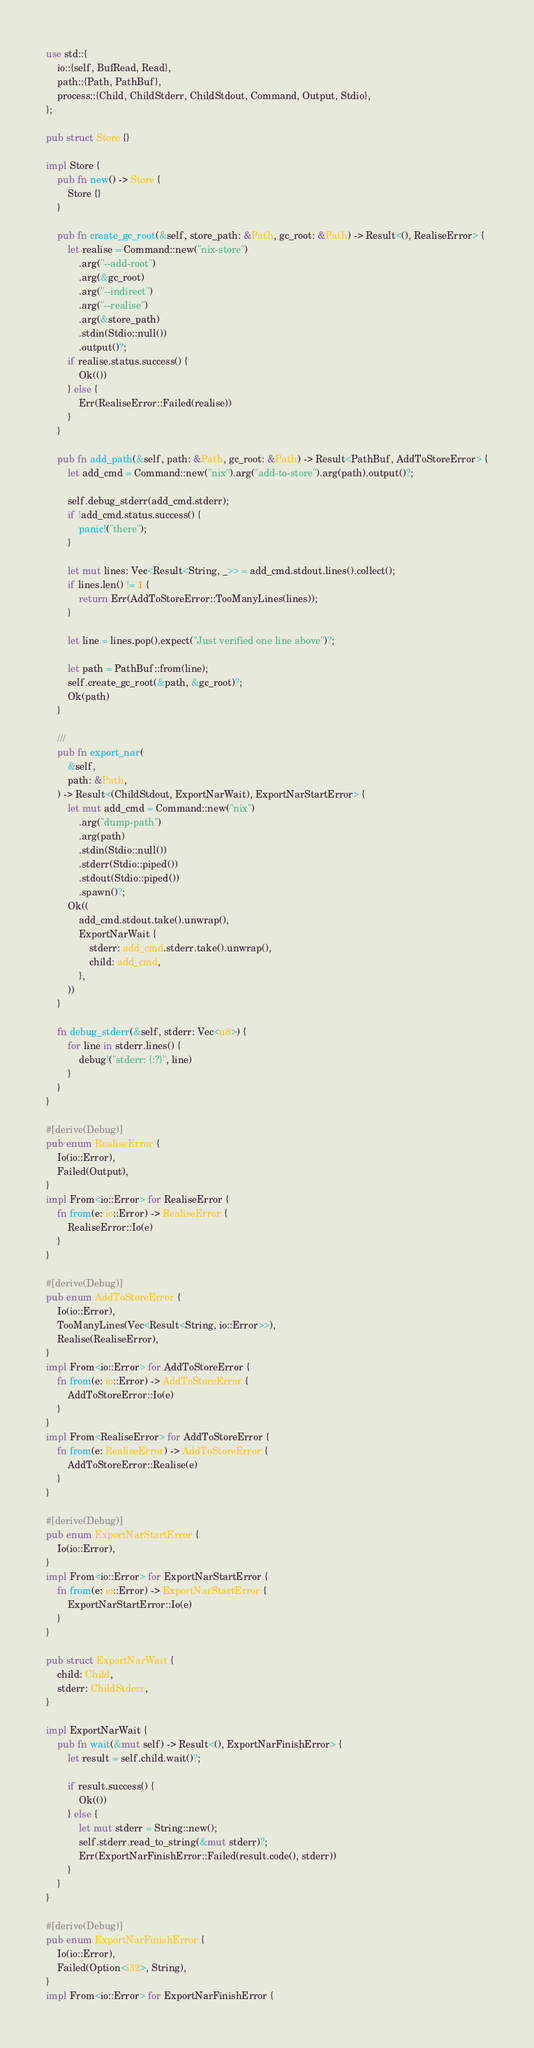<code> <loc_0><loc_0><loc_500><loc_500><_Rust_>use std::{
    io::{self, BufRead, Read},
    path::{Path, PathBuf},
    process::{Child, ChildStderr, ChildStdout, Command, Output, Stdio},
};

pub struct Store {}

impl Store {
    pub fn new() -> Store {
        Store {}
    }

    pub fn create_gc_root(&self, store_path: &Path, gc_root: &Path) -> Result<(), RealiseError> {
        let realise = Command::new("nix-store")
            .arg("--add-root")
            .arg(&gc_root)
            .arg("--indirect")
            .arg("--realise")
            .arg(&store_path)
            .stdin(Stdio::null())
            .output()?;
        if realise.status.success() {
            Ok(())
        } else {
            Err(RealiseError::Failed(realise))
        }
    }

    pub fn add_path(&self, path: &Path, gc_root: &Path) -> Result<PathBuf, AddToStoreError> {
        let add_cmd = Command::new("nix").arg("add-to-store").arg(path).output()?;

        self.debug_stderr(add_cmd.stderr);
        if !add_cmd.status.success() {
            panic!("there");
        }

        let mut lines: Vec<Result<String, _>> = add_cmd.stdout.lines().collect();
        if lines.len() != 1 {
            return Err(AddToStoreError::TooManyLines(lines));
        }

        let line = lines.pop().expect("Just verified one line above")?;

        let path = PathBuf::from(line);
        self.create_gc_root(&path, &gc_root)?;
        Ok(path)
    }

    ///
    pub fn export_nar(
        &self,
        path: &Path,
    ) -> Result<(ChildStdout, ExportNarWait), ExportNarStartError> {
        let mut add_cmd = Command::new("nix")
            .arg("dump-path")
            .arg(path)
            .stdin(Stdio::null())
            .stderr(Stdio::piped())
            .stdout(Stdio::piped())
            .spawn()?;
        Ok((
            add_cmd.stdout.take().unwrap(),
            ExportNarWait {
                stderr: add_cmd.stderr.take().unwrap(),
                child: add_cmd,
            },
        ))
    }

    fn debug_stderr(&self, stderr: Vec<u8>) {
        for line in stderr.lines() {
            debug!("stderr: {:?}", line)
        }
    }
}

#[derive(Debug)]
pub enum RealiseError {
    Io(io::Error),
    Failed(Output),
}
impl From<io::Error> for RealiseError {
    fn from(e: io::Error) -> RealiseError {
        RealiseError::Io(e)
    }
}

#[derive(Debug)]
pub enum AddToStoreError {
    Io(io::Error),
    TooManyLines(Vec<Result<String, io::Error>>),
    Realise(RealiseError),
}
impl From<io::Error> for AddToStoreError {
    fn from(e: io::Error) -> AddToStoreError {
        AddToStoreError::Io(e)
    }
}
impl From<RealiseError> for AddToStoreError {
    fn from(e: RealiseError) -> AddToStoreError {
        AddToStoreError::Realise(e)
    }
}

#[derive(Debug)]
pub enum ExportNarStartError {
    Io(io::Error),
}
impl From<io::Error> for ExportNarStartError {
    fn from(e: io::Error) -> ExportNarStartError {
        ExportNarStartError::Io(e)
    }
}

pub struct ExportNarWait {
    child: Child,
    stderr: ChildStderr,
}

impl ExportNarWait {
    pub fn wait(&mut self) -> Result<(), ExportNarFinishError> {
        let result = self.child.wait()?;

        if result.success() {
            Ok(())
        } else {
            let mut stderr = String::new();
            self.stderr.read_to_string(&mut stderr)?;
            Err(ExportNarFinishError::Failed(result.code(), stderr))
        }
    }
}

#[derive(Debug)]
pub enum ExportNarFinishError {
    Io(io::Error),
    Failed(Option<i32>, String),
}
impl From<io::Error> for ExportNarFinishError {</code> 